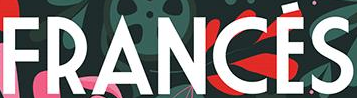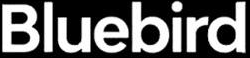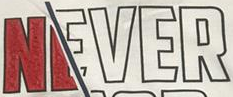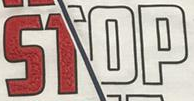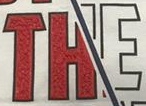Read the text content from these images in order, separated by a semicolon. FRANCÉS; Bluebird; NEVER; STOP; THE 